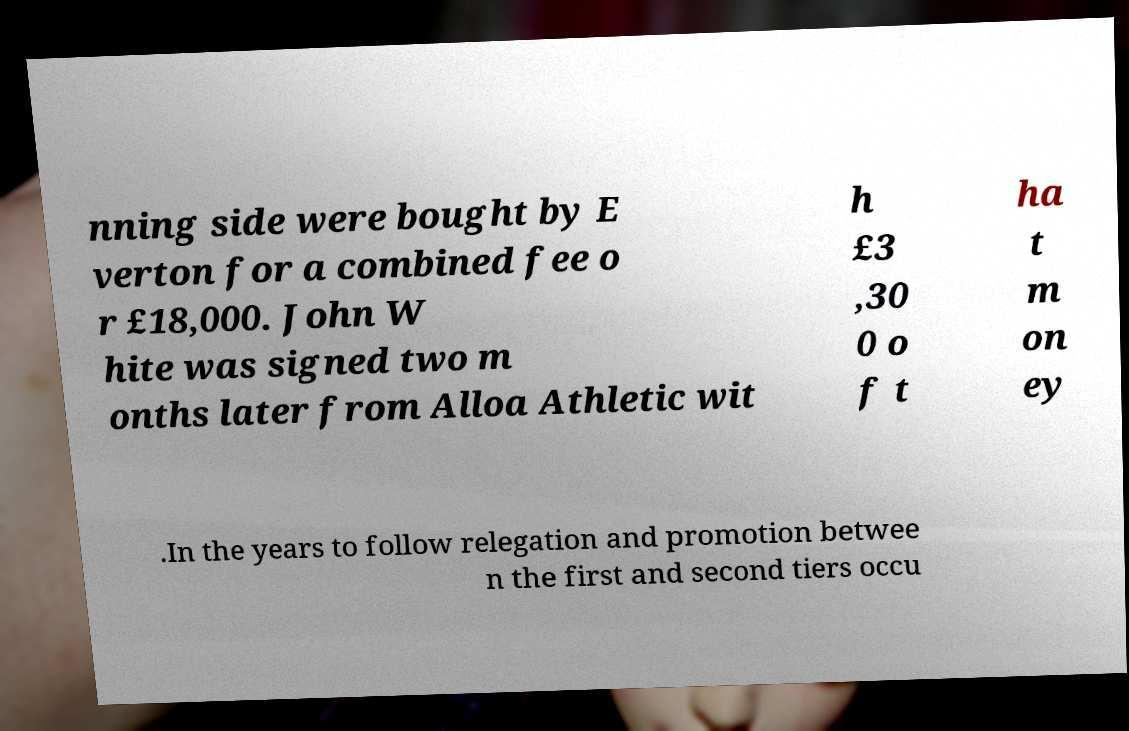Can you read and provide the text displayed in the image?This photo seems to have some interesting text. Can you extract and type it out for me? nning side were bought by E verton for a combined fee o r £18,000. John W hite was signed two m onths later from Alloa Athletic wit h £3 ,30 0 o f t ha t m on ey .In the years to follow relegation and promotion betwee n the first and second tiers occu 